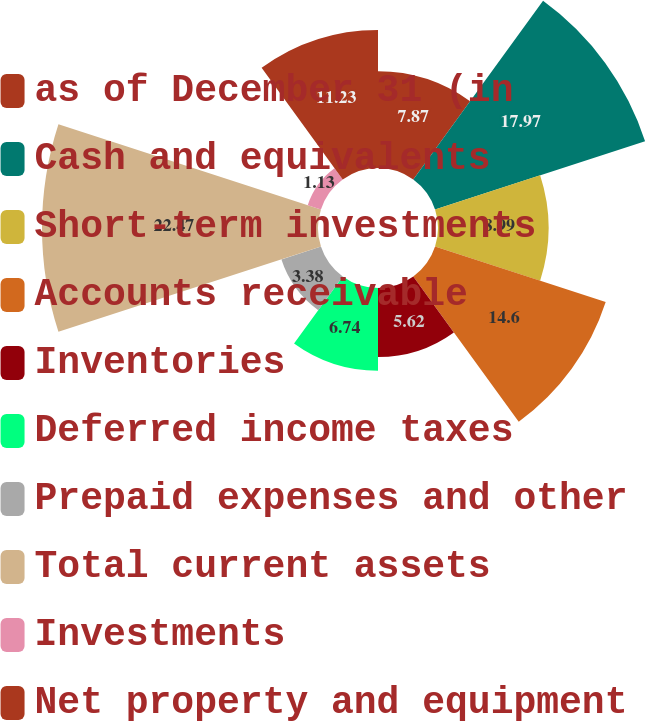Convert chart. <chart><loc_0><loc_0><loc_500><loc_500><pie_chart><fcel>as of December 31 (in<fcel>Cash and equivalents<fcel>Short-term investments<fcel>Accounts receivable<fcel>Inventories<fcel>Deferred income taxes<fcel>Prepaid expenses and other<fcel>Total current assets<fcel>Investments<fcel>Net property and equipment<nl><fcel>7.87%<fcel>17.97%<fcel>8.99%<fcel>14.6%<fcel>5.62%<fcel>6.74%<fcel>3.38%<fcel>22.46%<fcel>1.13%<fcel>11.23%<nl></chart> 